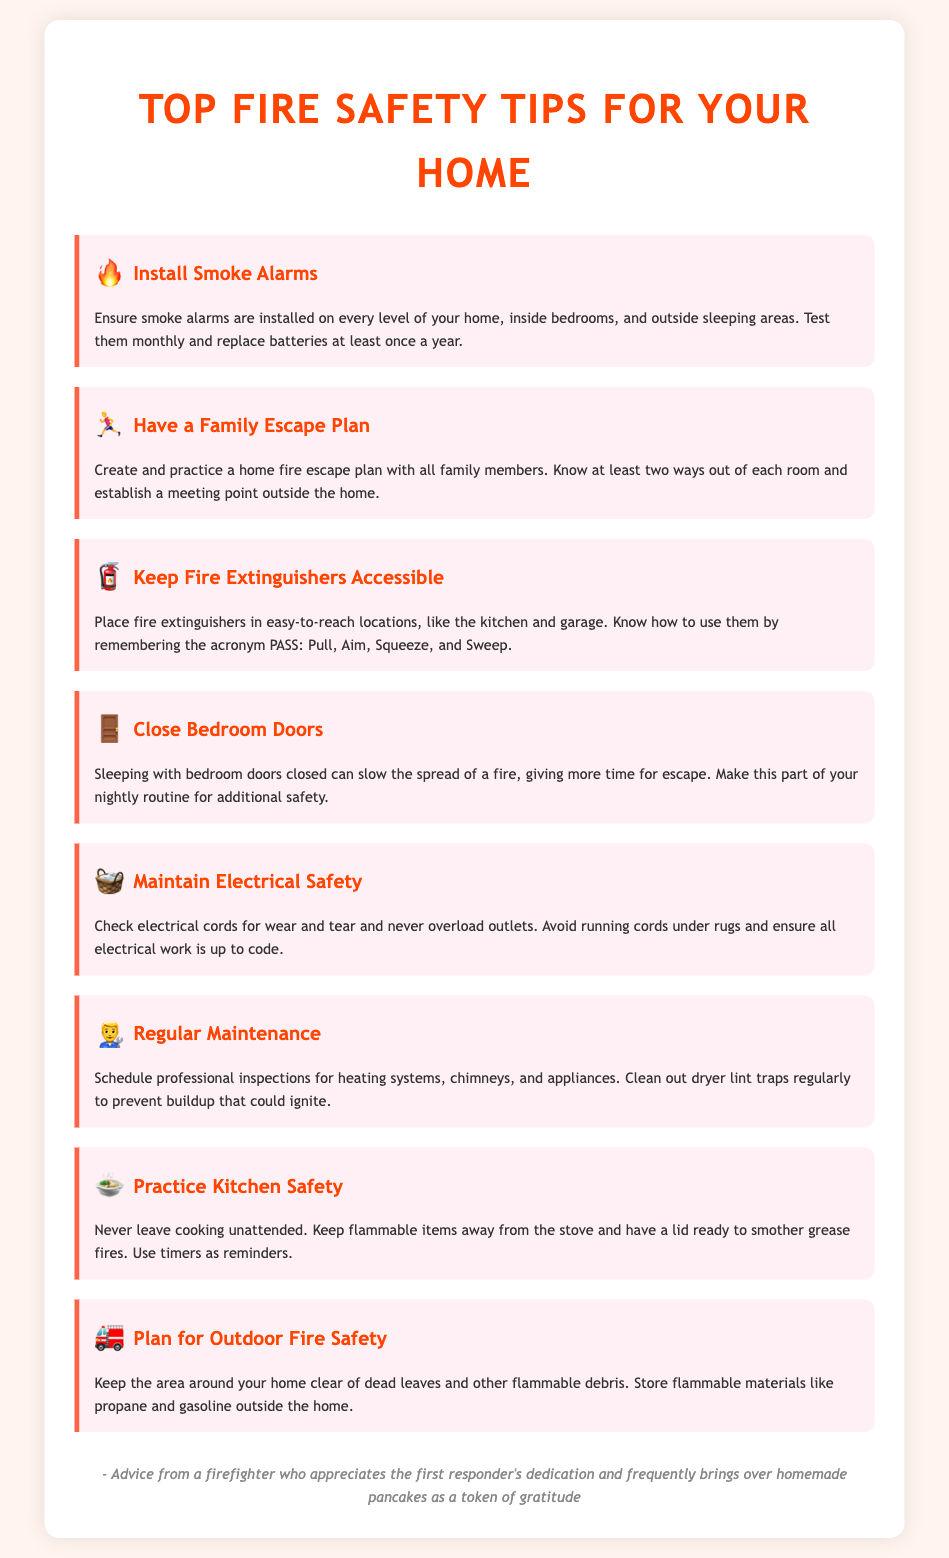What are the tips for fire safety? The document provides various tips categorized to enhance fire safety at home.
Answer: Install Smoke Alarms, Have a Family Escape Plan, Keep Fire Extinguishers Accessible, Close Bedroom Doors, Maintain Electrical Safety, Regular Maintenance, Practice Kitchen Safety, Plan for Outdoor Fire Safety How often should smoke alarm batteries be replaced? The document states that smoke alarm batteries should be replaced at least once a year.
Answer: Once a year What does the acronym PASS stand for? The document explains that PASS stands for Pull, Aim, Squeeze, Sweep, used for fire extinguisher usage.
Answer: Pull, Aim, Squeeze, Sweep Why is it important to practice a family escape plan? The document indicates that practicing an escape plan ensures all family members know how to exit safely in case of a fire.
Answer: To ensure safe exits How can closing bedroom doors help during a fire? The document mentions that sleeping with bedroom doors closed can slow the spread of a fire.
Answer: Slow the spread of fire Which area should fire extinguishers be placed? The document highlights that fire extinguishers should be placed in easy-to-reach locations like the kitchen and garage.
Answer: Kitchen and garage What should be kept away from the stove during cooking? The document warns to keep flammable items away from the stove while cooking.
Answer: Flammable items What is a good way to remind you when cooking? The document suggests using timers to remind when cooking.
Answer: Timers What should be regularly inspected for safety? The document specifies that heating systems, chimneys, and appliances should be regularly inspected for safety.
Answer: Heating systems, chimneys, appliances 